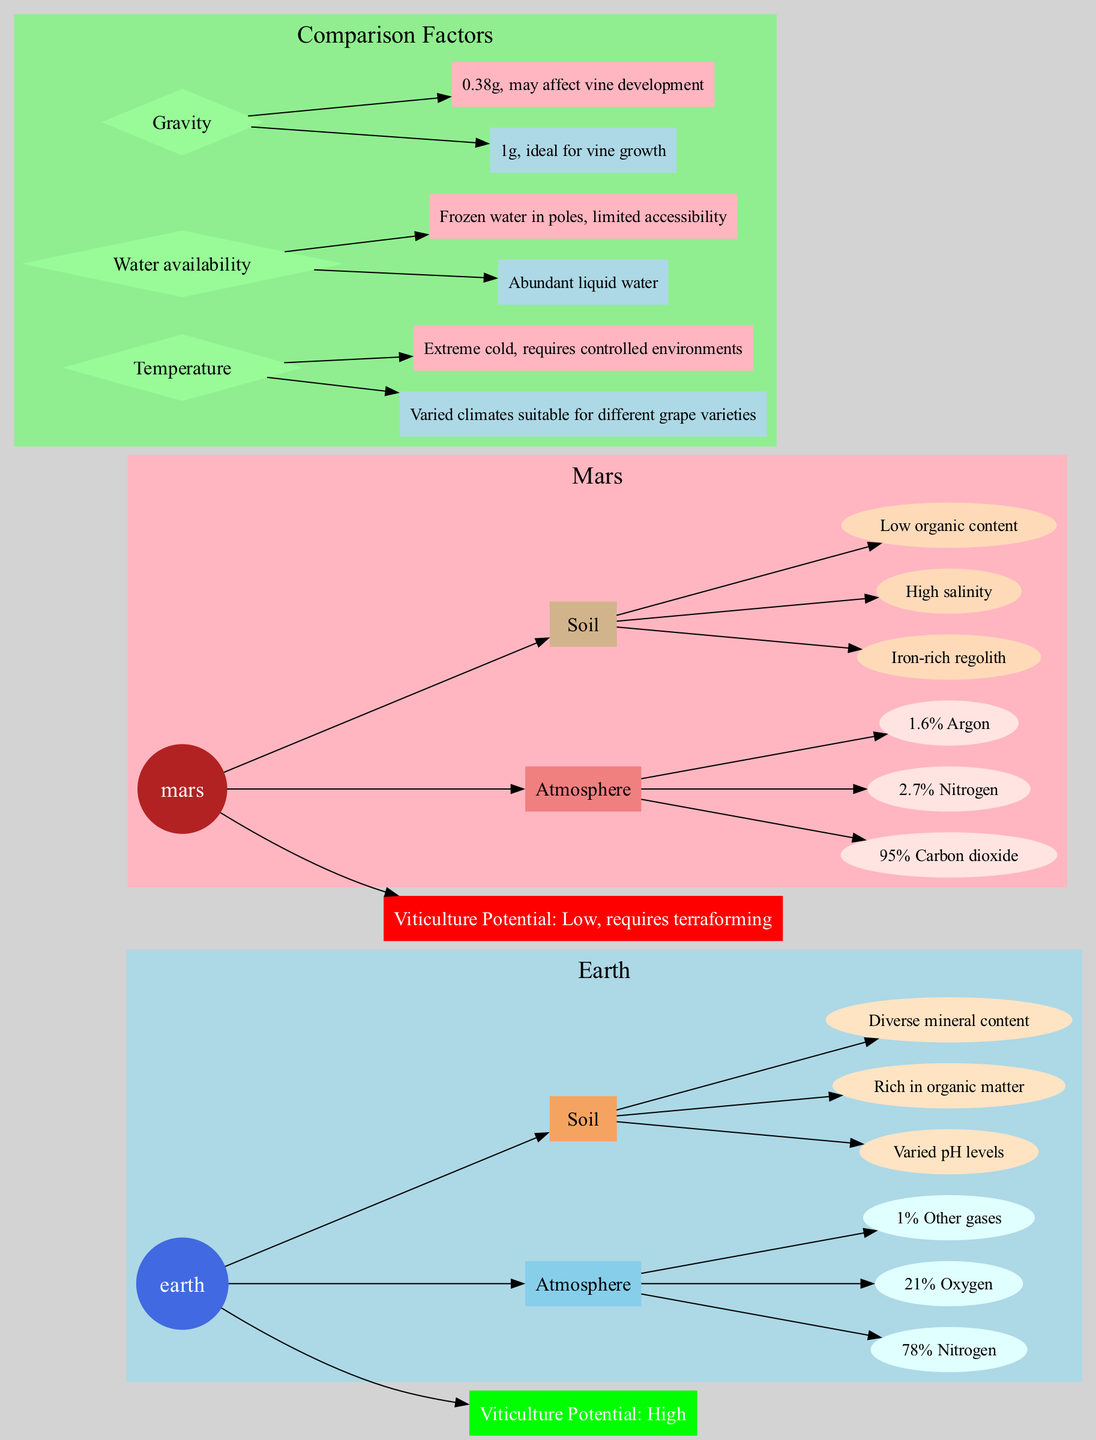What is the primary gas in Earth's atmosphere? Earth's atmosphere composition shows that nitrogen makes up 78% of it, which is the largest single component. Therefore, the primary gas is nitrogen.
Answer: Nitrogen How many soil characteristics are listed for Mars? The diagram lists three specific soil characteristics for Mars, which are iron-rich regolith, high salinity, and low organic content. Counting these gives a total of three.
Answer: 3 What is Mars' viticulture potential? According to the diagram, Mars has a low viticulture potential, which is explicitly stated as needing terraforming for improvement.
Answer: Low, requires terraforming Which planet has abundant liquid water? The diagram indicates that Earth has abundant liquid water, while Mars has frozen water in limited accessibility. The specific mention of "abundant liquid water" directly points to Earth.
Answer: Earth How does gravity on Mars compare to that on Earth? The comparison section states that Earth's gravity is 1g, which is ideal for vine growth, while Mars has a lower gravity of 0.38g. This indicates a significant difference, highlighting the challenges for vine growth on Mars.
Answer: 0.38g What are the three components of Mars' atmosphere? The diagram displays Mars' atmosphere as consisting primarily of 95% carbon dioxide, along with 2.7% nitrogen and 1.6% argon. Listing these components gives: carbon dioxide, nitrogen, argon.
Answer: Carbon dioxide, nitrogen, argon Which factor shows that Earth is more suitable for viticulture? The diagram indicates that Earth has varied climates suitable for different grape varieties, compared to Mars' extreme cold which requires controlled environments. This highlights Earth's advantages for viticulture.
Answer: Varied climates What is the color used to represent Mars in the diagram? The diagram uses firebrick color to represent Mars, which is shown in the node specifically labeled for Mars to distinguish it from Earth.
Answer: Firebrick How many atmosphere components are listed for Earth? The Earth’s atmosphere features three components indicated on the diagram: nitrogen, oxygen, and other gases, thus the count is three.
Answer: 3 